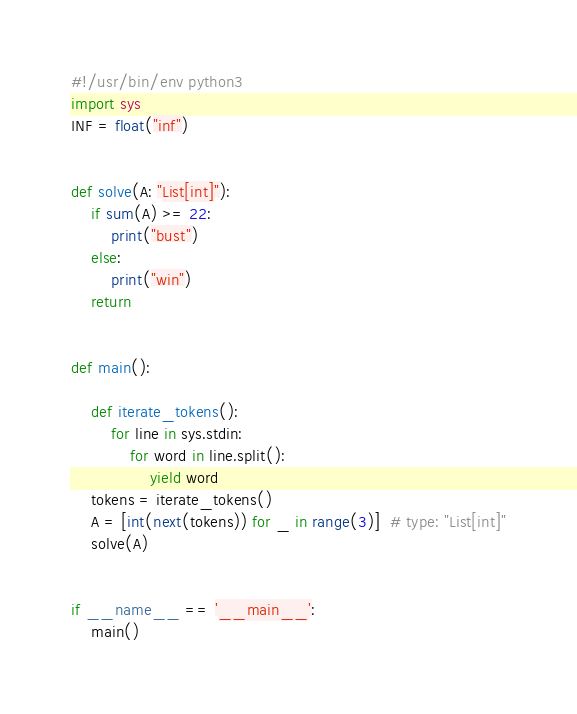Convert code to text. <code><loc_0><loc_0><loc_500><loc_500><_Python_>#!/usr/bin/env python3
import sys
INF = float("inf")


def solve(A: "List[int]"):
    if sum(A) >= 22:
        print("bust")
    else:
        print("win")
    return


def main():

    def iterate_tokens():
        for line in sys.stdin:
            for word in line.split():
                yield word
    tokens = iterate_tokens()
    A = [int(next(tokens)) for _ in range(3)]  # type: "List[int]"
    solve(A)


if __name__ == '__main__':
    main()
</code> 